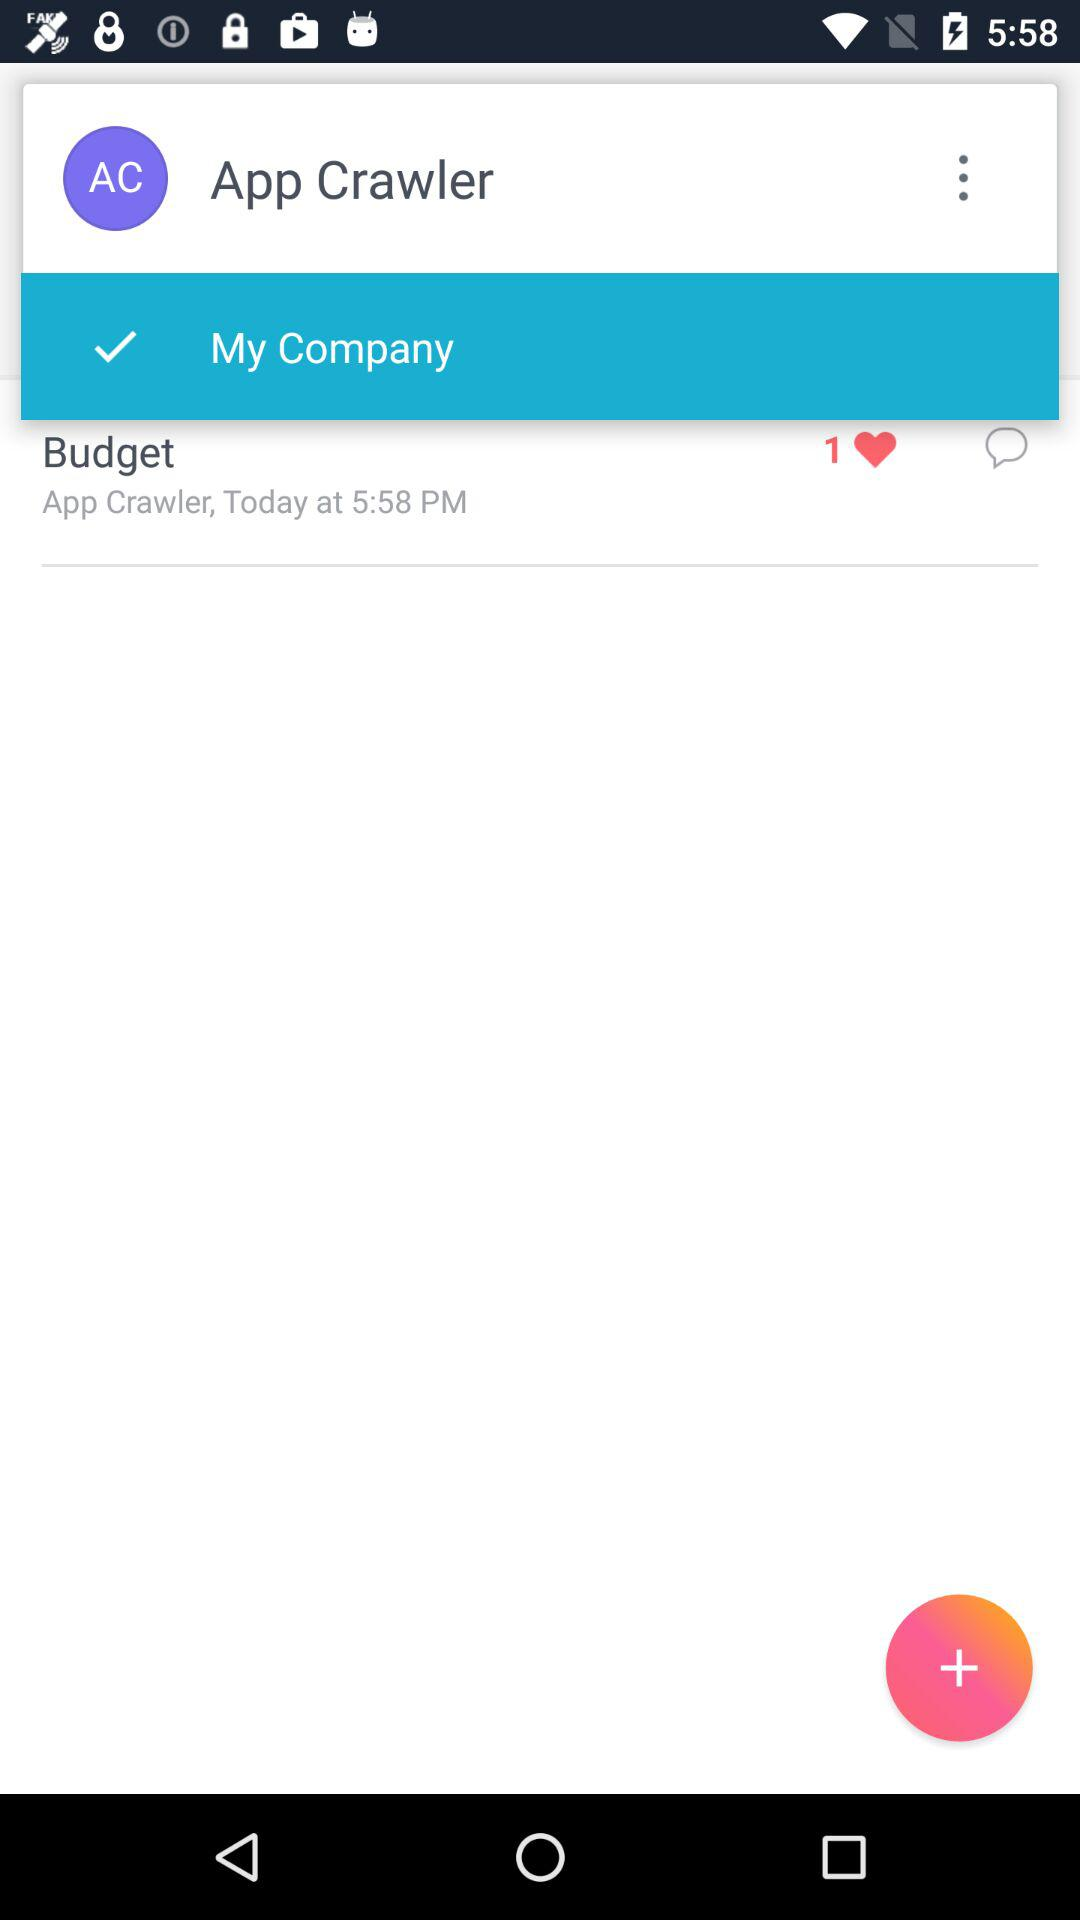What is the mentioned time in the "Budget"? The mentioned time in the "Budget" is 5:58 PM. 